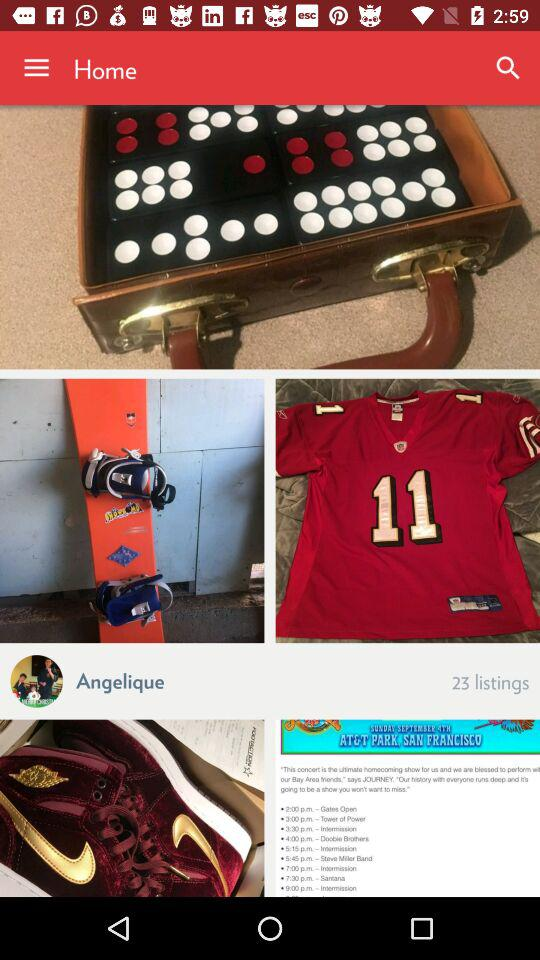How many listings are there? There are 23 listings. 